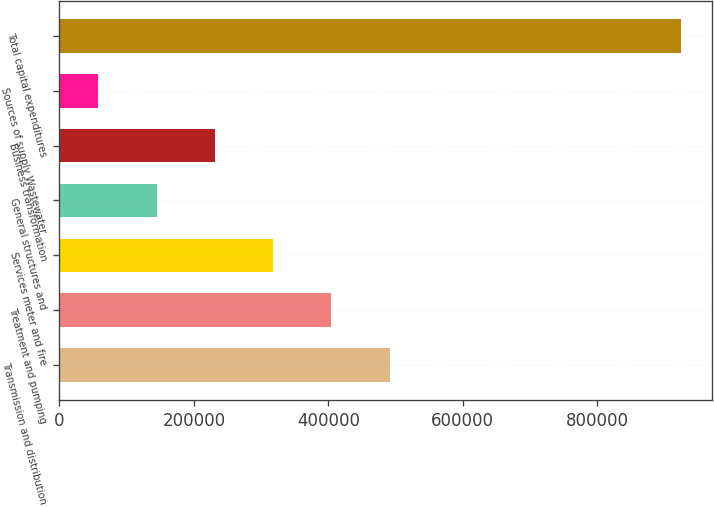<chart> <loc_0><loc_0><loc_500><loc_500><bar_chart><fcel>Transmission and distribution<fcel>Treatment and pumping<fcel>Services meter and fire<fcel>General structures and<fcel>Business transformation<fcel>Sources of supply Wastewater<fcel>Total capital expenditures<nl><fcel>491462<fcel>404783<fcel>318104<fcel>144745<fcel>231424<fcel>58066<fcel>924858<nl></chart> 